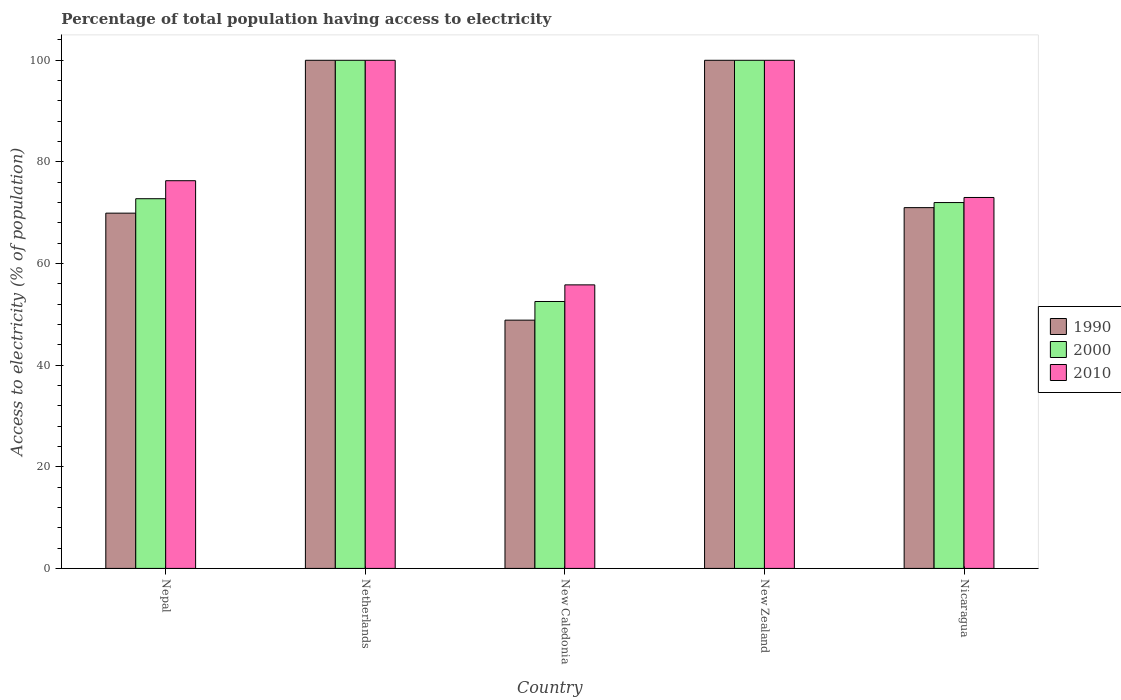How many groups of bars are there?
Offer a very short reply. 5. How many bars are there on the 2nd tick from the left?
Ensure brevity in your answer.  3. How many bars are there on the 1st tick from the right?
Your answer should be compact. 3. What is the label of the 2nd group of bars from the left?
Give a very brief answer. Netherlands. In how many cases, is the number of bars for a given country not equal to the number of legend labels?
Ensure brevity in your answer.  0. What is the percentage of population that have access to electricity in 2000 in Nicaragua?
Keep it short and to the point. 72. Across all countries, what is the maximum percentage of population that have access to electricity in 2000?
Give a very brief answer. 100. Across all countries, what is the minimum percentage of population that have access to electricity in 1990?
Provide a succinct answer. 48.86. In which country was the percentage of population that have access to electricity in 2000 minimum?
Give a very brief answer. New Caledonia. What is the total percentage of population that have access to electricity in 1990 in the graph?
Make the answer very short. 389.77. What is the difference between the percentage of population that have access to electricity in 1990 in Nepal and that in Nicaragua?
Offer a very short reply. -1.08. What is the difference between the percentage of population that have access to electricity in 2000 in New Zealand and the percentage of population that have access to electricity in 1990 in Nicaragua?
Your response must be concise. 29. What is the average percentage of population that have access to electricity in 2000 per country?
Offer a very short reply. 79.46. What is the difference between the percentage of population that have access to electricity of/in 2010 and percentage of population that have access to electricity of/in 1990 in New Caledonia?
Your answer should be very brief. 6.94. What is the ratio of the percentage of population that have access to electricity in 2010 in New Caledonia to that in New Zealand?
Your answer should be very brief. 0.56. Is the percentage of population that have access to electricity in 1990 in Nepal less than that in Netherlands?
Give a very brief answer. Yes. Is the difference between the percentage of population that have access to electricity in 2010 in New Zealand and Nicaragua greater than the difference between the percentage of population that have access to electricity in 1990 in New Zealand and Nicaragua?
Your response must be concise. No. What is the difference between the highest and the second highest percentage of population that have access to electricity in 2010?
Provide a succinct answer. 23.7. What is the difference between the highest and the lowest percentage of population that have access to electricity in 2000?
Ensure brevity in your answer.  47.47. Is the sum of the percentage of population that have access to electricity in 2010 in Netherlands and Nicaragua greater than the maximum percentage of population that have access to electricity in 1990 across all countries?
Provide a succinct answer. Yes. What does the 2nd bar from the left in New Caledonia represents?
Give a very brief answer. 2000. How many bars are there?
Your answer should be compact. 15. What is the difference between two consecutive major ticks on the Y-axis?
Provide a short and direct response. 20. Where does the legend appear in the graph?
Offer a terse response. Center right. What is the title of the graph?
Give a very brief answer. Percentage of total population having access to electricity. Does "1972" appear as one of the legend labels in the graph?
Provide a short and direct response. No. What is the label or title of the Y-axis?
Give a very brief answer. Access to electricity (% of population). What is the Access to electricity (% of population) of 1990 in Nepal?
Provide a short and direct response. 69.92. What is the Access to electricity (% of population) in 2000 in Nepal?
Ensure brevity in your answer.  72.76. What is the Access to electricity (% of population) in 2010 in Nepal?
Keep it short and to the point. 76.3. What is the Access to electricity (% of population) in 2000 in Netherlands?
Offer a very short reply. 100. What is the Access to electricity (% of population) in 1990 in New Caledonia?
Offer a very short reply. 48.86. What is the Access to electricity (% of population) in 2000 in New Caledonia?
Offer a terse response. 52.53. What is the Access to electricity (% of population) of 2010 in New Caledonia?
Keep it short and to the point. 55.8. What is the Access to electricity (% of population) of 1990 in New Zealand?
Your answer should be compact. 100. What is the Access to electricity (% of population) in 2000 in New Zealand?
Offer a terse response. 100. What is the Access to electricity (% of population) of 2010 in New Zealand?
Provide a succinct answer. 100. What is the Access to electricity (% of population) of 1990 in Nicaragua?
Keep it short and to the point. 71. What is the Access to electricity (% of population) of 2000 in Nicaragua?
Provide a succinct answer. 72. What is the Access to electricity (% of population) of 2010 in Nicaragua?
Provide a short and direct response. 73. Across all countries, what is the minimum Access to electricity (% of population) in 1990?
Your answer should be very brief. 48.86. Across all countries, what is the minimum Access to electricity (% of population) of 2000?
Your answer should be very brief. 52.53. Across all countries, what is the minimum Access to electricity (% of population) of 2010?
Ensure brevity in your answer.  55.8. What is the total Access to electricity (% of population) in 1990 in the graph?
Offer a terse response. 389.77. What is the total Access to electricity (% of population) of 2000 in the graph?
Make the answer very short. 397.29. What is the total Access to electricity (% of population) of 2010 in the graph?
Provide a succinct answer. 405.1. What is the difference between the Access to electricity (% of population) in 1990 in Nepal and that in Netherlands?
Make the answer very short. -30.08. What is the difference between the Access to electricity (% of population) of 2000 in Nepal and that in Netherlands?
Ensure brevity in your answer.  -27.24. What is the difference between the Access to electricity (% of population) in 2010 in Nepal and that in Netherlands?
Make the answer very short. -23.7. What is the difference between the Access to electricity (% of population) of 1990 in Nepal and that in New Caledonia?
Your answer should be compact. 21.06. What is the difference between the Access to electricity (% of population) of 2000 in Nepal and that in New Caledonia?
Make the answer very short. 20.23. What is the difference between the Access to electricity (% of population) in 1990 in Nepal and that in New Zealand?
Your response must be concise. -30.08. What is the difference between the Access to electricity (% of population) in 2000 in Nepal and that in New Zealand?
Provide a succinct answer. -27.24. What is the difference between the Access to electricity (% of population) of 2010 in Nepal and that in New Zealand?
Offer a very short reply. -23.7. What is the difference between the Access to electricity (% of population) in 1990 in Nepal and that in Nicaragua?
Provide a short and direct response. -1.08. What is the difference between the Access to electricity (% of population) in 2000 in Nepal and that in Nicaragua?
Make the answer very short. 0.76. What is the difference between the Access to electricity (% of population) in 2010 in Nepal and that in Nicaragua?
Ensure brevity in your answer.  3.3. What is the difference between the Access to electricity (% of population) of 1990 in Netherlands and that in New Caledonia?
Your response must be concise. 51.14. What is the difference between the Access to electricity (% of population) in 2000 in Netherlands and that in New Caledonia?
Make the answer very short. 47.47. What is the difference between the Access to electricity (% of population) of 2010 in Netherlands and that in New Caledonia?
Your response must be concise. 44.2. What is the difference between the Access to electricity (% of population) in 2010 in Netherlands and that in New Zealand?
Provide a short and direct response. 0. What is the difference between the Access to electricity (% of population) in 1990 in Netherlands and that in Nicaragua?
Offer a very short reply. 29. What is the difference between the Access to electricity (% of population) of 2010 in Netherlands and that in Nicaragua?
Offer a very short reply. 27. What is the difference between the Access to electricity (% of population) in 1990 in New Caledonia and that in New Zealand?
Your answer should be very brief. -51.14. What is the difference between the Access to electricity (% of population) in 2000 in New Caledonia and that in New Zealand?
Offer a very short reply. -47.47. What is the difference between the Access to electricity (% of population) of 2010 in New Caledonia and that in New Zealand?
Ensure brevity in your answer.  -44.2. What is the difference between the Access to electricity (% of population) of 1990 in New Caledonia and that in Nicaragua?
Provide a succinct answer. -22.14. What is the difference between the Access to electricity (% of population) of 2000 in New Caledonia and that in Nicaragua?
Your answer should be compact. -19.47. What is the difference between the Access to electricity (% of population) in 2010 in New Caledonia and that in Nicaragua?
Your response must be concise. -17.2. What is the difference between the Access to electricity (% of population) in 1990 in New Zealand and that in Nicaragua?
Your answer should be compact. 29. What is the difference between the Access to electricity (% of population) of 1990 in Nepal and the Access to electricity (% of population) of 2000 in Netherlands?
Make the answer very short. -30.08. What is the difference between the Access to electricity (% of population) of 1990 in Nepal and the Access to electricity (% of population) of 2010 in Netherlands?
Offer a terse response. -30.08. What is the difference between the Access to electricity (% of population) in 2000 in Nepal and the Access to electricity (% of population) in 2010 in Netherlands?
Offer a terse response. -27.24. What is the difference between the Access to electricity (% of population) in 1990 in Nepal and the Access to electricity (% of population) in 2000 in New Caledonia?
Ensure brevity in your answer.  17.39. What is the difference between the Access to electricity (% of population) in 1990 in Nepal and the Access to electricity (% of population) in 2010 in New Caledonia?
Your response must be concise. 14.12. What is the difference between the Access to electricity (% of population) in 2000 in Nepal and the Access to electricity (% of population) in 2010 in New Caledonia?
Your response must be concise. 16.96. What is the difference between the Access to electricity (% of population) of 1990 in Nepal and the Access to electricity (% of population) of 2000 in New Zealand?
Ensure brevity in your answer.  -30.08. What is the difference between the Access to electricity (% of population) in 1990 in Nepal and the Access to electricity (% of population) in 2010 in New Zealand?
Offer a terse response. -30.08. What is the difference between the Access to electricity (% of population) of 2000 in Nepal and the Access to electricity (% of population) of 2010 in New Zealand?
Keep it short and to the point. -27.24. What is the difference between the Access to electricity (% of population) of 1990 in Nepal and the Access to electricity (% of population) of 2000 in Nicaragua?
Your answer should be compact. -2.08. What is the difference between the Access to electricity (% of population) of 1990 in Nepal and the Access to electricity (% of population) of 2010 in Nicaragua?
Provide a short and direct response. -3.08. What is the difference between the Access to electricity (% of population) in 2000 in Nepal and the Access to electricity (% of population) in 2010 in Nicaragua?
Keep it short and to the point. -0.24. What is the difference between the Access to electricity (% of population) of 1990 in Netherlands and the Access to electricity (% of population) of 2000 in New Caledonia?
Offer a very short reply. 47.47. What is the difference between the Access to electricity (% of population) in 1990 in Netherlands and the Access to electricity (% of population) in 2010 in New Caledonia?
Give a very brief answer. 44.2. What is the difference between the Access to electricity (% of population) in 2000 in Netherlands and the Access to electricity (% of population) in 2010 in New Caledonia?
Offer a very short reply. 44.2. What is the difference between the Access to electricity (% of population) of 1990 in Netherlands and the Access to electricity (% of population) of 2010 in New Zealand?
Provide a short and direct response. 0. What is the difference between the Access to electricity (% of population) in 2000 in Netherlands and the Access to electricity (% of population) in 2010 in New Zealand?
Provide a short and direct response. 0. What is the difference between the Access to electricity (% of population) of 1990 in Netherlands and the Access to electricity (% of population) of 2010 in Nicaragua?
Your response must be concise. 27. What is the difference between the Access to electricity (% of population) in 1990 in New Caledonia and the Access to electricity (% of population) in 2000 in New Zealand?
Your answer should be very brief. -51.14. What is the difference between the Access to electricity (% of population) in 1990 in New Caledonia and the Access to electricity (% of population) in 2010 in New Zealand?
Offer a terse response. -51.14. What is the difference between the Access to electricity (% of population) of 2000 in New Caledonia and the Access to electricity (% of population) of 2010 in New Zealand?
Give a very brief answer. -47.47. What is the difference between the Access to electricity (% of population) in 1990 in New Caledonia and the Access to electricity (% of population) in 2000 in Nicaragua?
Offer a very short reply. -23.14. What is the difference between the Access to electricity (% of population) of 1990 in New Caledonia and the Access to electricity (% of population) of 2010 in Nicaragua?
Provide a succinct answer. -24.14. What is the difference between the Access to electricity (% of population) of 2000 in New Caledonia and the Access to electricity (% of population) of 2010 in Nicaragua?
Give a very brief answer. -20.47. What is the difference between the Access to electricity (% of population) in 2000 in New Zealand and the Access to electricity (% of population) in 2010 in Nicaragua?
Keep it short and to the point. 27. What is the average Access to electricity (% of population) in 1990 per country?
Provide a short and direct response. 77.95. What is the average Access to electricity (% of population) of 2000 per country?
Give a very brief answer. 79.46. What is the average Access to electricity (% of population) in 2010 per country?
Make the answer very short. 81.02. What is the difference between the Access to electricity (% of population) of 1990 and Access to electricity (% of population) of 2000 in Nepal?
Offer a terse response. -2.84. What is the difference between the Access to electricity (% of population) of 1990 and Access to electricity (% of population) of 2010 in Nepal?
Your response must be concise. -6.38. What is the difference between the Access to electricity (% of population) of 2000 and Access to electricity (% of population) of 2010 in Nepal?
Your answer should be compact. -3.54. What is the difference between the Access to electricity (% of population) in 1990 and Access to electricity (% of population) in 2000 in Netherlands?
Your answer should be very brief. 0. What is the difference between the Access to electricity (% of population) in 1990 and Access to electricity (% of population) in 2000 in New Caledonia?
Keep it short and to the point. -3.67. What is the difference between the Access to electricity (% of population) in 1990 and Access to electricity (% of population) in 2010 in New Caledonia?
Your answer should be very brief. -6.94. What is the difference between the Access to electricity (% of population) in 2000 and Access to electricity (% of population) in 2010 in New Caledonia?
Provide a short and direct response. -3.27. What is the difference between the Access to electricity (% of population) of 2000 and Access to electricity (% of population) of 2010 in New Zealand?
Provide a succinct answer. 0. What is the difference between the Access to electricity (% of population) of 2000 and Access to electricity (% of population) of 2010 in Nicaragua?
Provide a short and direct response. -1. What is the ratio of the Access to electricity (% of population) in 1990 in Nepal to that in Netherlands?
Your answer should be very brief. 0.7. What is the ratio of the Access to electricity (% of population) of 2000 in Nepal to that in Netherlands?
Your answer should be very brief. 0.73. What is the ratio of the Access to electricity (% of population) in 2010 in Nepal to that in Netherlands?
Make the answer very short. 0.76. What is the ratio of the Access to electricity (% of population) of 1990 in Nepal to that in New Caledonia?
Your answer should be compact. 1.43. What is the ratio of the Access to electricity (% of population) in 2000 in Nepal to that in New Caledonia?
Offer a terse response. 1.39. What is the ratio of the Access to electricity (% of population) in 2010 in Nepal to that in New Caledonia?
Offer a terse response. 1.37. What is the ratio of the Access to electricity (% of population) in 1990 in Nepal to that in New Zealand?
Keep it short and to the point. 0.7. What is the ratio of the Access to electricity (% of population) in 2000 in Nepal to that in New Zealand?
Offer a very short reply. 0.73. What is the ratio of the Access to electricity (% of population) in 2010 in Nepal to that in New Zealand?
Your response must be concise. 0.76. What is the ratio of the Access to electricity (% of population) of 1990 in Nepal to that in Nicaragua?
Provide a short and direct response. 0.98. What is the ratio of the Access to electricity (% of population) of 2000 in Nepal to that in Nicaragua?
Make the answer very short. 1.01. What is the ratio of the Access to electricity (% of population) of 2010 in Nepal to that in Nicaragua?
Your answer should be compact. 1.05. What is the ratio of the Access to electricity (% of population) of 1990 in Netherlands to that in New Caledonia?
Provide a succinct answer. 2.05. What is the ratio of the Access to electricity (% of population) of 2000 in Netherlands to that in New Caledonia?
Your answer should be very brief. 1.9. What is the ratio of the Access to electricity (% of population) of 2010 in Netherlands to that in New Caledonia?
Keep it short and to the point. 1.79. What is the ratio of the Access to electricity (% of population) in 1990 in Netherlands to that in New Zealand?
Offer a very short reply. 1. What is the ratio of the Access to electricity (% of population) in 2000 in Netherlands to that in New Zealand?
Keep it short and to the point. 1. What is the ratio of the Access to electricity (% of population) in 1990 in Netherlands to that in Nicaragua?
Keep it short and to the point. 1.41. What is the ratio of the Access to electricity (% of population) of 2000 in Netherlands to that in Nicaragua?
Your answer should be compact. 1.39. What is the ratio of the Access to electricity (% of population) in 2010 in Netherlands to that in Nicaragua?
Provide a succinct answer. 1.37. What is the ratio of the Access to electricity (% of population) in 1990 in New Caledonia to that in New Zealand?
Provide a succinct answer. 0.49. What is the ratio of the Access to electricity (% of population) of 2000 in New Caledonia to that in New Zealand?
Offer a terse response. 0.53. What is the ratio of the Access to electricity (% of population) in 2010 in New Caledonia to that in New Zealand?
Provide a succinct answer. 0.56. What is the ratio of the Access to electricity (% of population) of 1990 in New Caledonia to that in Nicaragua?
Your answer should be very brief. 0.69. What is the ratio of the Access to electricity (% of population) in 2000 in New Caledonia to that in Nicaragua?
Provide a short and direct response. 0.73. What is the ratio of the Access to electricity (% of population) of 2010 in New Caledonia to that in Nicaragua?
Your answer should be very brief. 0.76. What is the ratio of the Access to electricity (% of population) of 1990 in New Zealand to that in Nicaragua?
Keep it short and to the point. 1.41. What is the ratio of the Access to electricity (% of population) in 2000 in New Zealand to that in Nicaragua?
Make the answer very short. 1.39. What is the ratio of the Access to electricity (% of population) of 2010 in New Zealand to that in Nicaragua?
Your answer should be compact. 1.37. What is the difference between the highest and the second highest Access to electricity (% of population) of 2000?
Your answer should be compact. 0. What is the difference between the highest and the second highest Access to electricity (% of population) in 2010?
Offer a terse response. 0. What is the difference between the highest and the lowest Access to electricity (% of population) of 1990?
Offer a very short reply. 51.14. What is the difference between the highest and the lowest Access to electricity (% of population) in 2000?
Make the answer very short. 47.47. What is the difference between the highest and the lowest Access to electricity (% of population) in 2010?
Your answer should be compact. 44.2. 